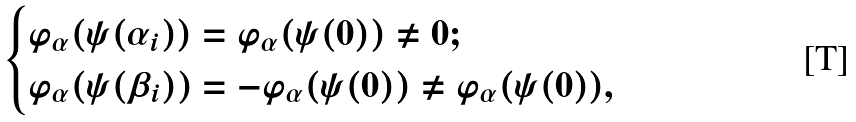<formula> <loc_0><loc_0><loc_500><loc_500>\begin{cases} \varphi _ { \alpha } ( \psi ( \alpha _ { i } ) ) = \varphi _ { \alpha } ( \psi ( 0 ) ) \neq 0 ; \\ \varphi _ { \alpha } ( \psi ( \beta _ { i } ) ) = - \varphi _ { \alpha } ( \psi ( 0 ) ) \neq \varphi _ { \alpha } ( \psi ( 0 ) ) , \end{cases}</formula> 